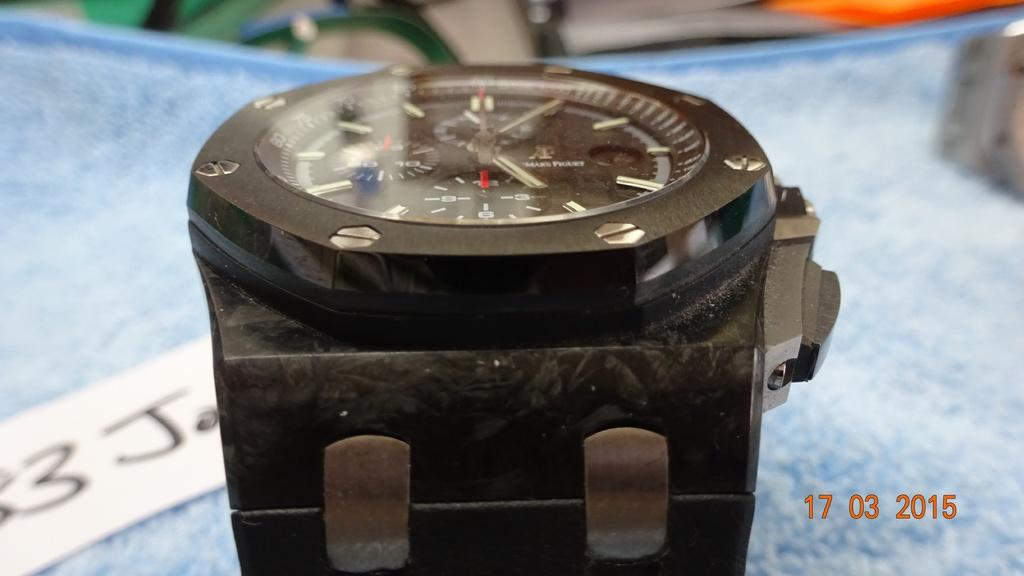<image>
Create a compact narrative representing the image presented. The picture of the watch shows a date in the bottom corner of 17 03 2015. 